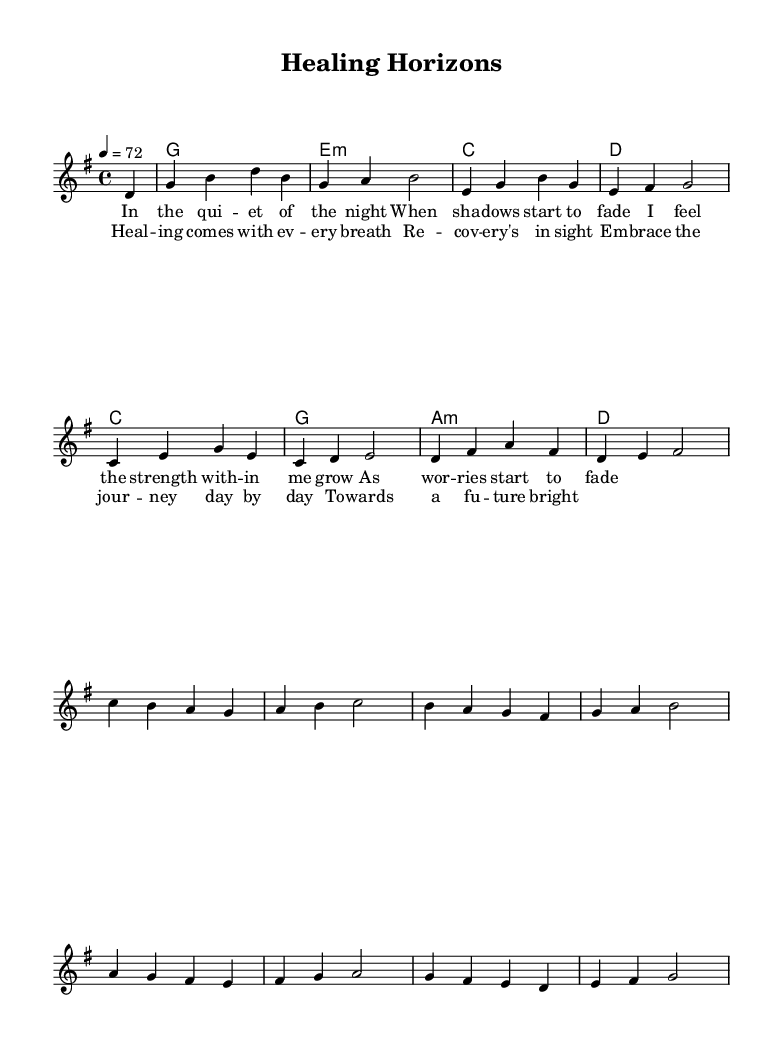What is the key signature of this music? The key signature is G major, which has one sharp (F#). This is identifiable by the raised note in the key signature at the beginning of the staff.
Answer: G major What is the time signature of this piece? The time signature is 4/4, which indicates four beats per measure and is shown at the beginning of the sheet music.
Answer: 4/4 What is the tempo marking for this piece? The tempo marking is 72 beats per minute, specified as "4 = 72" in the score, indicating the quarter note is counted at 72 beats per minute.
Answer: 72 What is the first lyric phrase of the verse? The first lyric phrase in the verse is "In the quiet of the night," which is presented below the melody in the lyric section.
Answer: In the quiet of the night How many measures are there in the chorus? The chorus consists of four measures, as counted from the measured sections of the music where the lyrics for the chorus are aligned.
Answer: 4 What feelings or themes are expressed in the chorus? The themes expressed in the chorus include healing and recovery, as demonstrated by the lyrics highlighting healing with every breath and embracing a journey toward a brighter future.
Answer: Healing and recovery What is the mood conveyed in this piece? The mood is calming and uplifting, described through the soothing melody and lyrics that focus on themes of healing and recovery, creating a sense of hope and tranquility.
Answer: Calming and uplifting 